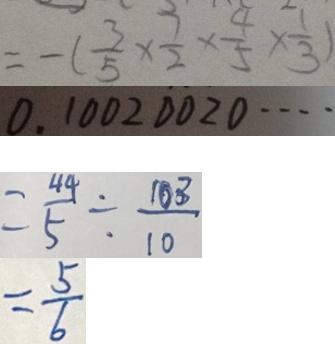<formula> <loc_0><loc_0><loc_500><loc_500>= - ( \frac { 3 } { 5 } \times \frac { 7 } { 2 } \times \frac { 4 } { 5 } \times \frac { 1 } { 3 } ) 
 0 . 1 0 0 2 0 0 2 0 \cdots 
 = \frac { 4 4 } { 5 } \div \frac { 1 0 3 } { 1 0 } 
 = \frac { 5 } { 6 }</formula> 